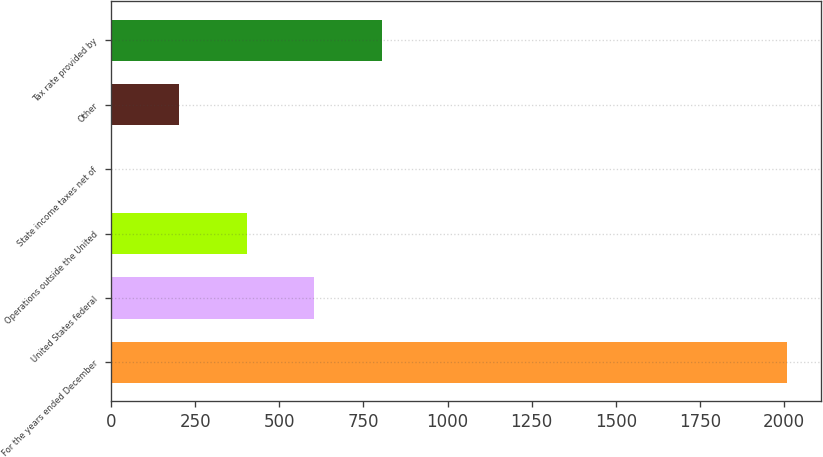<chart> <loc_0><loc_0><loc_500><loc_500><bar_chart><fcel>For the years ended December<fcel>United States federal<fcel>Operations outside the United<fcel>State income taxes net of<fcel>Other<fcel>Tax rate provided by<nl><fcel>2010<fcel>603.7<fcel>402.8<fcel>1<fcel>201.9<fcel>804.6<nl></chart> 